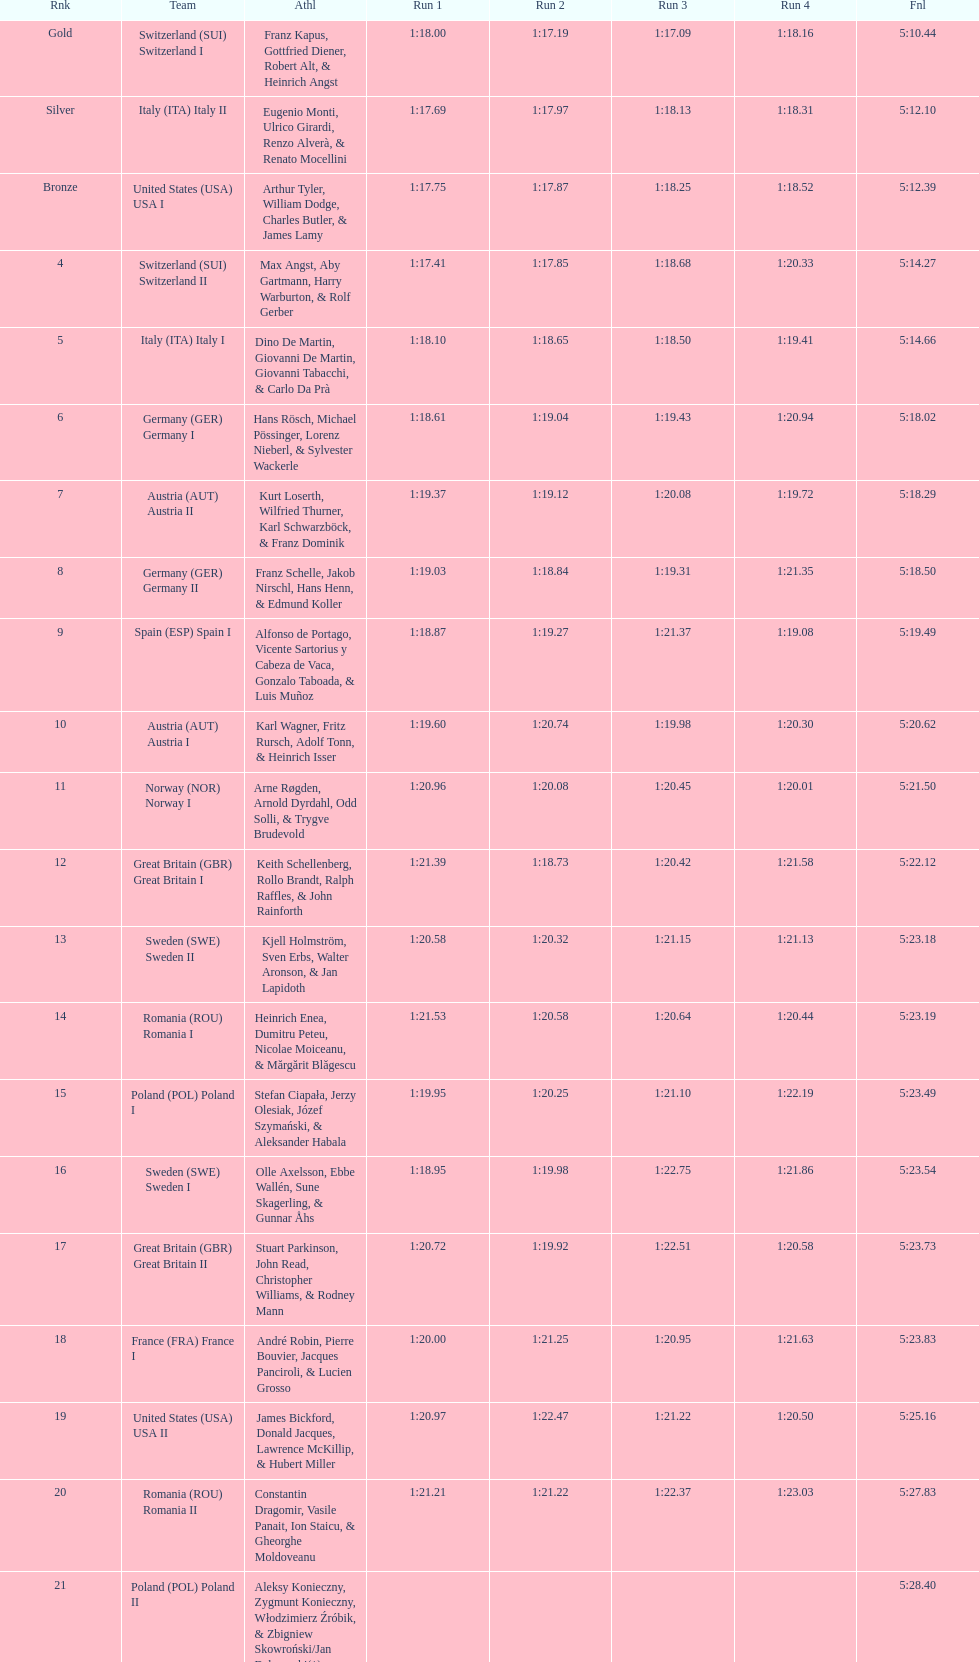Would you mind parsing the complete table? {'header': ['Rnk', 'Team', 'Athl', 'Run 1', 'Run 2', 'Run 3', 'Run 4', 'Fnl'], 'rows': [['Gold', 'Switzerland\xa0(SUI) Switzerland I', 'Franz Kapus, Gottfried Diener, Robert Alt, & Heinrich Angst', '1:18.00', '1:17.19', '1:17.09', '1:18.16', '5:10.44'], ['Silver', 'Italy\xa0(ITA) Italy II', 'Eugenio Monti, Ulrico Girardi, Renzo Alverà, & Renato Mocellini', '1:17.69', '1:17.97', '1:18.13', '1:18.31', '5:12.10'], ['Bronze', 'United States\xa0(USA) USA I', 'Arthur Tyler, William Dodge, Charles Butler, & James Lamy', '1:17.75', '1:17.87', '1:18.25', '1:18.52', '5:12.39'], ['4', 'Switzerland\xa0(SUI) Switzerland II', 'Max Angst, Aby Gartmann, Harry Warburton, & Rolf Gerber', '1:17.41', '1:17.85', '1:18.68', '1:20.33', '5:14.27'], ['5', 'Italy\xa0(ITA) Italy I', 'Dino De Martin, Giovanni De Martin, Giovanni Tabacchi, & Carlo Da Prà', '1:18.10', '1:18.65', '1:18.50', '1:19.41', '5:14.66'], ['6', 'Germany\xa0(GER) Germany I', 'Hans Rösch, Michael Pössinger, Lorenz Nieberl, & Sylvester Wackerle', '1:18.61', '1:19.04', '1:19.43', '1:20.94', '5:18.02'], ['7', 'Austria\xa0(AUT) Austria II', 'Kurt Loserth, Wilfried Thurner, Karl Schwarzböck, & Franz Dominik', '1:19.37', '1:19.12', '1:20.08', '1:19.72', '5:18.29'], ['8', 'Germany\xa0(GER) Germany II', 'Franz Schelle, Jakob Nirschl, Hans Henn, & Edmund Koller', '1:19.03', '1:18.84', '1:19.31', '1:21.35', '5:18.50'], ['9', 'Spain\xa0(ESP) Spain I', 'Alfonso de Portago, Vicente Sartorius y Cabeza de Vaca, Gonzalo Taboada, & Luis Muñoz', '1:18.87', '1:19.27', '1:21.37', '1:19.08', '5:19.49'], ['10', 'Austria\xa0(AUT) Austria I', 'Karl Wagner, Fritz Rursch, Adolf Tonn, & Heinrich Isser', '1:19.60', '1:20.74', '1:19.98', '1:20.30', '5:20.62'], ['11', 'Norway\xa0(NOR) Norway I', 'Arne Røgden, Arnold Dyrdahl, Odd Solli, & Trygve Brudevold', '1:20.96', '1:20.08', '1:20.45', '1:20.01', '5:21.50'], ['12', 'Great Britain\xa0(GBR) Great Britain I', 'Keith Schellenberg, Rollo Brandt, Ralph Raffles, & John Rainforth', '1:21.39', '1:18.73', '1:20.42', '1:21.58', '5:22.12'], ['13', 'Sweden\xa0(SWE) Sweden II', 'Kjell Holmström, Sven Erbs, Walter Aronson, & Jan Lapidoth', '1:20.58', '1:20.32', '1:21.15', '1:21.13', '5:23.18'], ['14', 'Romania\xa0(ROU) Romania I', 'Heinrich Enea, Dumitru Peteu, Nicolae Moiceanu, & Mărgărit Blăgescu', '1:21.53', '1:20.58', '1:20.64', '1:20.44', '5:23.19'], ['15', 'Poland\xa0(POL) Poland I', 'Stefan Ciapała, Jerzy Olesiak, Józef Szymański, & Aleksander Habala', '1:19.95', '1:20.25', '1:21.10', '1:22.19', '5:23.49'], ['16', 'Sweden\xa0(SWE) Sweden I', 'Olle Axelsson, Ebbe Wallén, Sune Skagerling, & Gunnar Åhs', '1:18.95', '1:19.98', '1:22.75', '1:21.86', '5:23.54'], ['17', 'Great Britain\xa0(GBR) Great Britain II', 'Stuart Parkinson, John Read, Christopher Williams, & Rodney Mann', '1:20.72', '1:19.92', '1:22.51', '1:20.58', '5:23.73'], ['18', 'France\xa0(FRA) France I', 'André Robin, Pierre Bouvier, Jacques Panciroli, & Lucien Grosso', '1:20.00', '1:21.25', '1:20.95', '1:21.63', '5:23.83'], ['19', 'United States\xa0(USA) USA II', 'James Bickford, Donald Jacques, Lawrence McKillip, & Hubert Miller', '1:20.97', '1:22.47', '1:21.22', '1:20.50', '5:25.16'], ['20', 'Romania\xa0(ROU) Romania II', 'Constantin Dragomir, Vasile Panait, Ion Staicu, & Gheorghe Moldoveanu', '1:21.21', '1:21.22', '1:22.37', '1:23.03', '5:27.83'], ['21', 'Poland\xa0(POL) Poland II', 'Aleksy Konieczny, Zygmunt Konieczny, Włodzimierz Źróbik, & Zbigniew Skowroński/Jan Dąbrowski(*)', '', '', '', '', '5:28.40']]} Who is the previous team to italy (ita) italy ii? Switzerland (SUI) Switzerland I. 